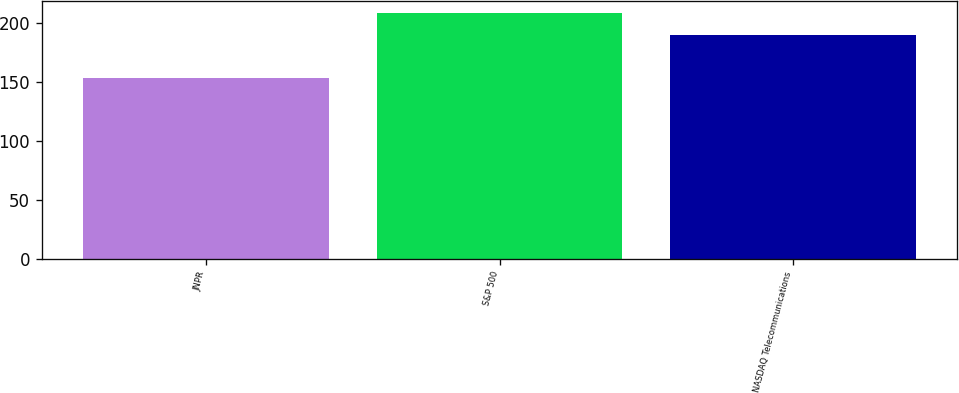<chart> <loc_0><loc_0><loc_500><loc_500><bar_chart><fcel>JNPR<fcel>S&P 500<fcel>NASDAQ Telecommunications<nl><fcel>152.97<fcel>208.05<fcel>190.02<nl></chart> 